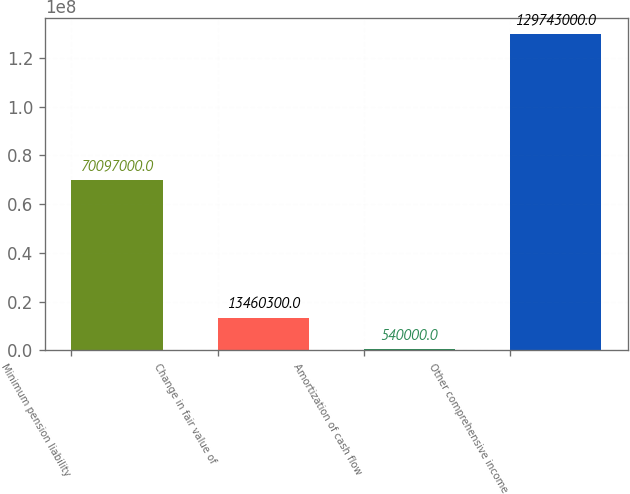<chart> <loc_0><loc_0><loc_500><loc_500><bar_chart><fcel>Minimum pension liability<fcel>Change in fair value of<fcel>Amortization of cash flow<fcel>Other comprehensive income<nl><fcel>7.0097e+07<fcel>1.34603e+07<fcel>540000<fcel>1.29743e+08<nl></chart> 